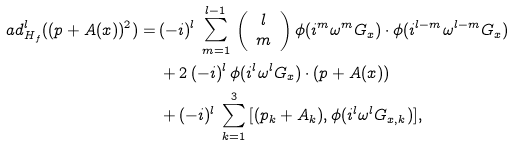Convert formula to latex. <formula><loc_0><loc_0><loc_500><loc_500>\ a d _ { H _ { f } } ^ { l } ( ( p + A ( x ) ) ^ { 2 } ) = \, & ( - i ) ^ { l } \, \sum _ { m = 1 } ^ { l - 1 } \, \left ( \begin{array} { c } l \\ m \end{array} \right ) \phi ( i ^ { m } \omega ^ { m } G _ { x } ) \cdot \phi ( i ^ { l - m } \omega ^ { l - m } G _ { x } ) \\ & + 2 \, ( - i ) ^ { l } \, \phi ( i ^ { l } \omega ^ { l } G _ { x } ) \cdot ( p + A ( x ) ) \\ & + ( - i ) ^ { l } \, \sum _ { k = 1 } ^ { 3 } \, [ ( p _ { k } + A _ { k } ) , \phi ( i ^ { l } \omega ^ { l } G _ { x , k } ) ] ,</formula> 